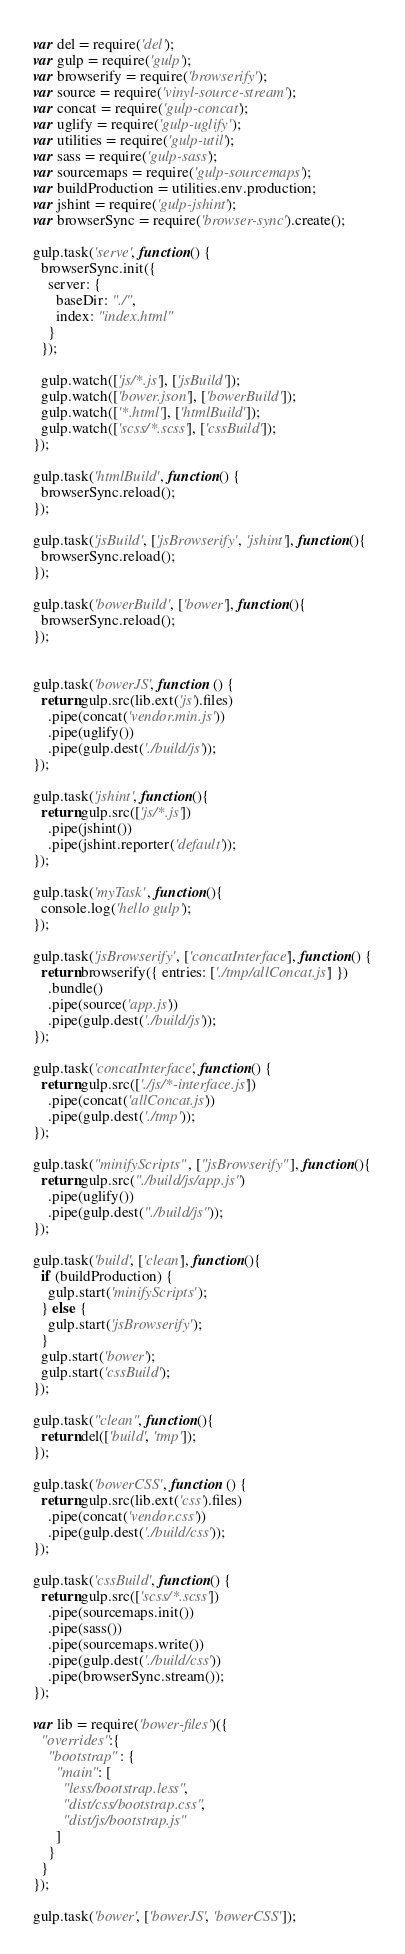<code> <loc_0><loc_0><loc_500><loc_500><_JavaScript_>var del = require('del');
var gulp = require('gulp');
var browserify = require('browserify');
var source = require('vinyl-source-stream');
var concat = require('gulp-concat');
var uglify = require('gulp-uglify');
var utilities = require('gulp-util');
var sass = require('gulp-sass');
var sourcemaps = require('gulp-sourcemaps');
var buildProduction = utilities.env.production;
var jshint = require('gulp-jshint');
var browserSync = require('browser-sync').create();

gulp.task('serve', function() {
  browserSync.init({
    server: {
      baseDir: "./",
      index: "index.html"
    }
  });

  gulp.watch(['js/*.js'], ['jsBuild']);
  gulp.watch(['bower.json'], ['bowerBuild']);
  gulp.watch(['*.html'], ['htmlBuild']);
  gulp.watch(['scss/*.scss'], ['cssBuild']);
});

gulp.task('htmlBuild', function() {
  browserSync.reload();
});

gulp.task('jsBuild', ['jsBrowserify', 'jshint'], function(){
  browserSync.reload();
});

gulp.task('bowerBuild', ['bower'], function(){
  browserSync.reload();
});


gulp.task('bowerJS', function () {
  return gulp.src(lib.ext('js').files)
    .pipe(concat('vendor.min.js'))
    .pipe(uglify())
    .pipe(gulp.dest('./build/js'));
});

gulp.task('jshint', function(){
  return gulp.src(['js/*.js'])
    .pipe(jshint())
    .pipe(jshint.reporter('default'));
});

gulp.task('myTask', function(){
  console.log('hello gulp');
});

gulp.task('jsBrowserify', ['concatInterface'], function() {
  return browserify({ entries: ['./tmp/allConcat.js'] })
    .bundle()
    .pipe(source('app.js'))
    .pipe(gulp.dest('./build/js'));
});

gulp.task('concatInterface', function() {
  return gulp.src(['./js/*-interface.js'])
    .pipe(concat('allConcat.js'))
    .pipe(gulp.dest('./tmp'));
});

gulp.task("minifyScripts", ["jsBrowserify"], function(){
  return gulp.src("./build/js/app.js")
    .pipe(uglify())
    .pipe(gulp.dest("./build/js"));
});

gulp.task('build', ['clean'], function(){
  if (buildProduction) {
    gulp.start('minifyScripts');
  } else {
    gulp.start('jsBrowserify');
  }
  gulp.start('bower');
  gulp.start('cssBuild');
});

gulp.task("clean", function(){
  return del(['build', 'tmp']);
});

gulp.task('bowerCSS', function () {
  return gulp.src(lib.ext('css').files)
    .pipe(concat('vendor.css'))
    .pipe(gulp.dest('./build/css'));
});

gulp.task('cssBuild', function() {
  return gulp.src(['scss/*.scss'])
    .pipe(sourcemaps.init())
    .pipe(sass())
    .pipe(sourcemaps.write())
    .pipe(gulp.dest('./build/css'))
    .pipe(browserSync.stream());
});

var lib = require('bower-files')({
  "overrides":{
    "bootstrap" : {
      "main": [
        "less/bootstrap.less",
        "dist/css/bootstrap.css",
        "dist/js/bootstrap.js"
      ]
    }
  }
});

gulp.task('bower', ['bowerJS', 'bowerCSS']);
</code> 